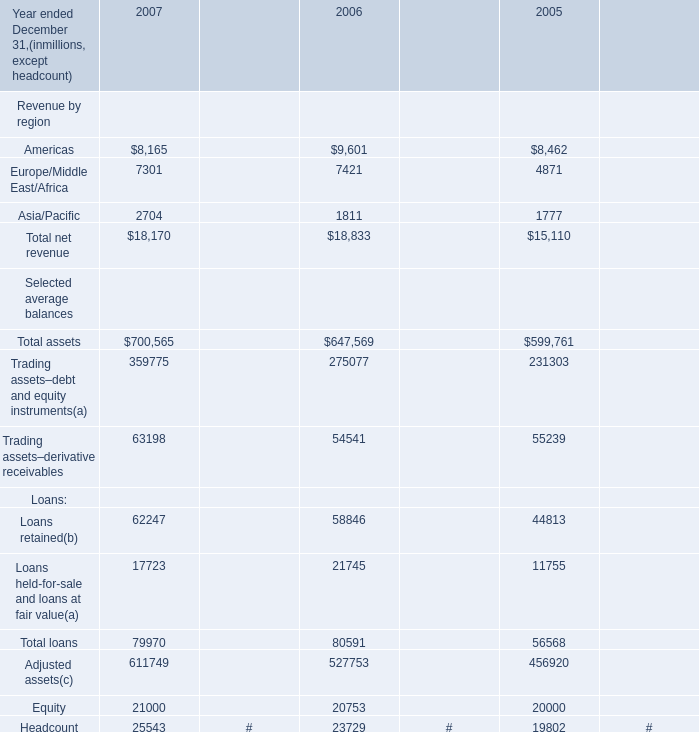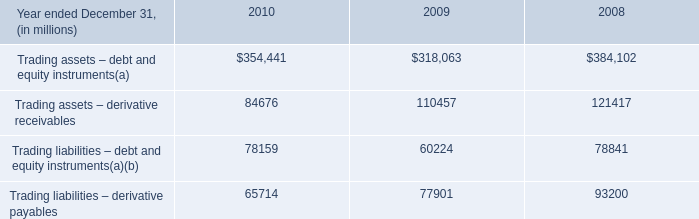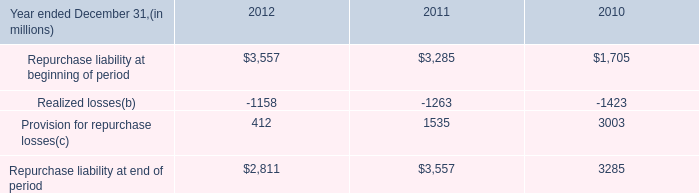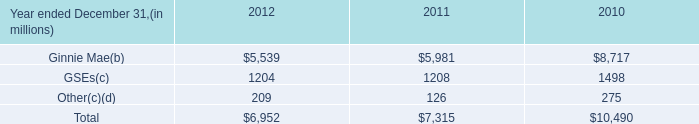Does the value of Americas in 2007 greater than that in 2006? 
Answer: No. 